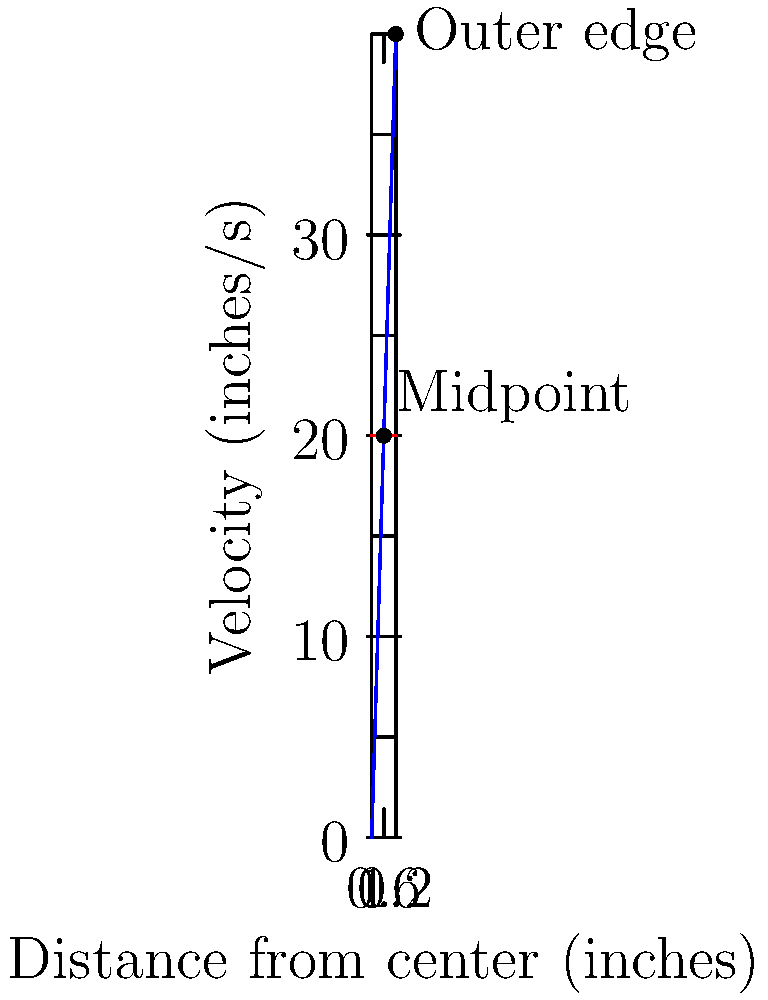A 12-inch vinyl record rotates at 33.33 RPM. Calculate the difference in linear velocity between a point on the outer edge of the record (6 inches from the center) and a point halfway between the center and the edge (3 inches from the center). Express your answer in inches per second. Let's approach this step-by-step:

1) First, we need to convert the angular velocity from RPM to radians per second:
   $$ \omega = 33.33 \text{ RPM} = 33.33 \cdot \frac{2\pi}{60} \approx 3.49 \text{ rad/s} $$

2) The linear velocity $v$ at a distance $r$ from the center is given by:
   $$ v = \omega r $$

3) For the outer edge (6 inches from center):
   $$ v_{\text{outer}} = 3.49 \cdot 6 \approx 20.94 \text{ inches/s} $$

4) For the midpoint (3 inches from center):
   $$ v_{\text{mid}} = 3.49 \cdot 3 \approx 10.47 \text{ inches/s} $$

5) The difference in velocity is:
   $$ \Delta v = v_{\text{outer}} - v_{\text{mid}} \approx 20.94 - 10.47 = 10.47 \text{ inches/s} $$
Answer: 10.47 inches/s 